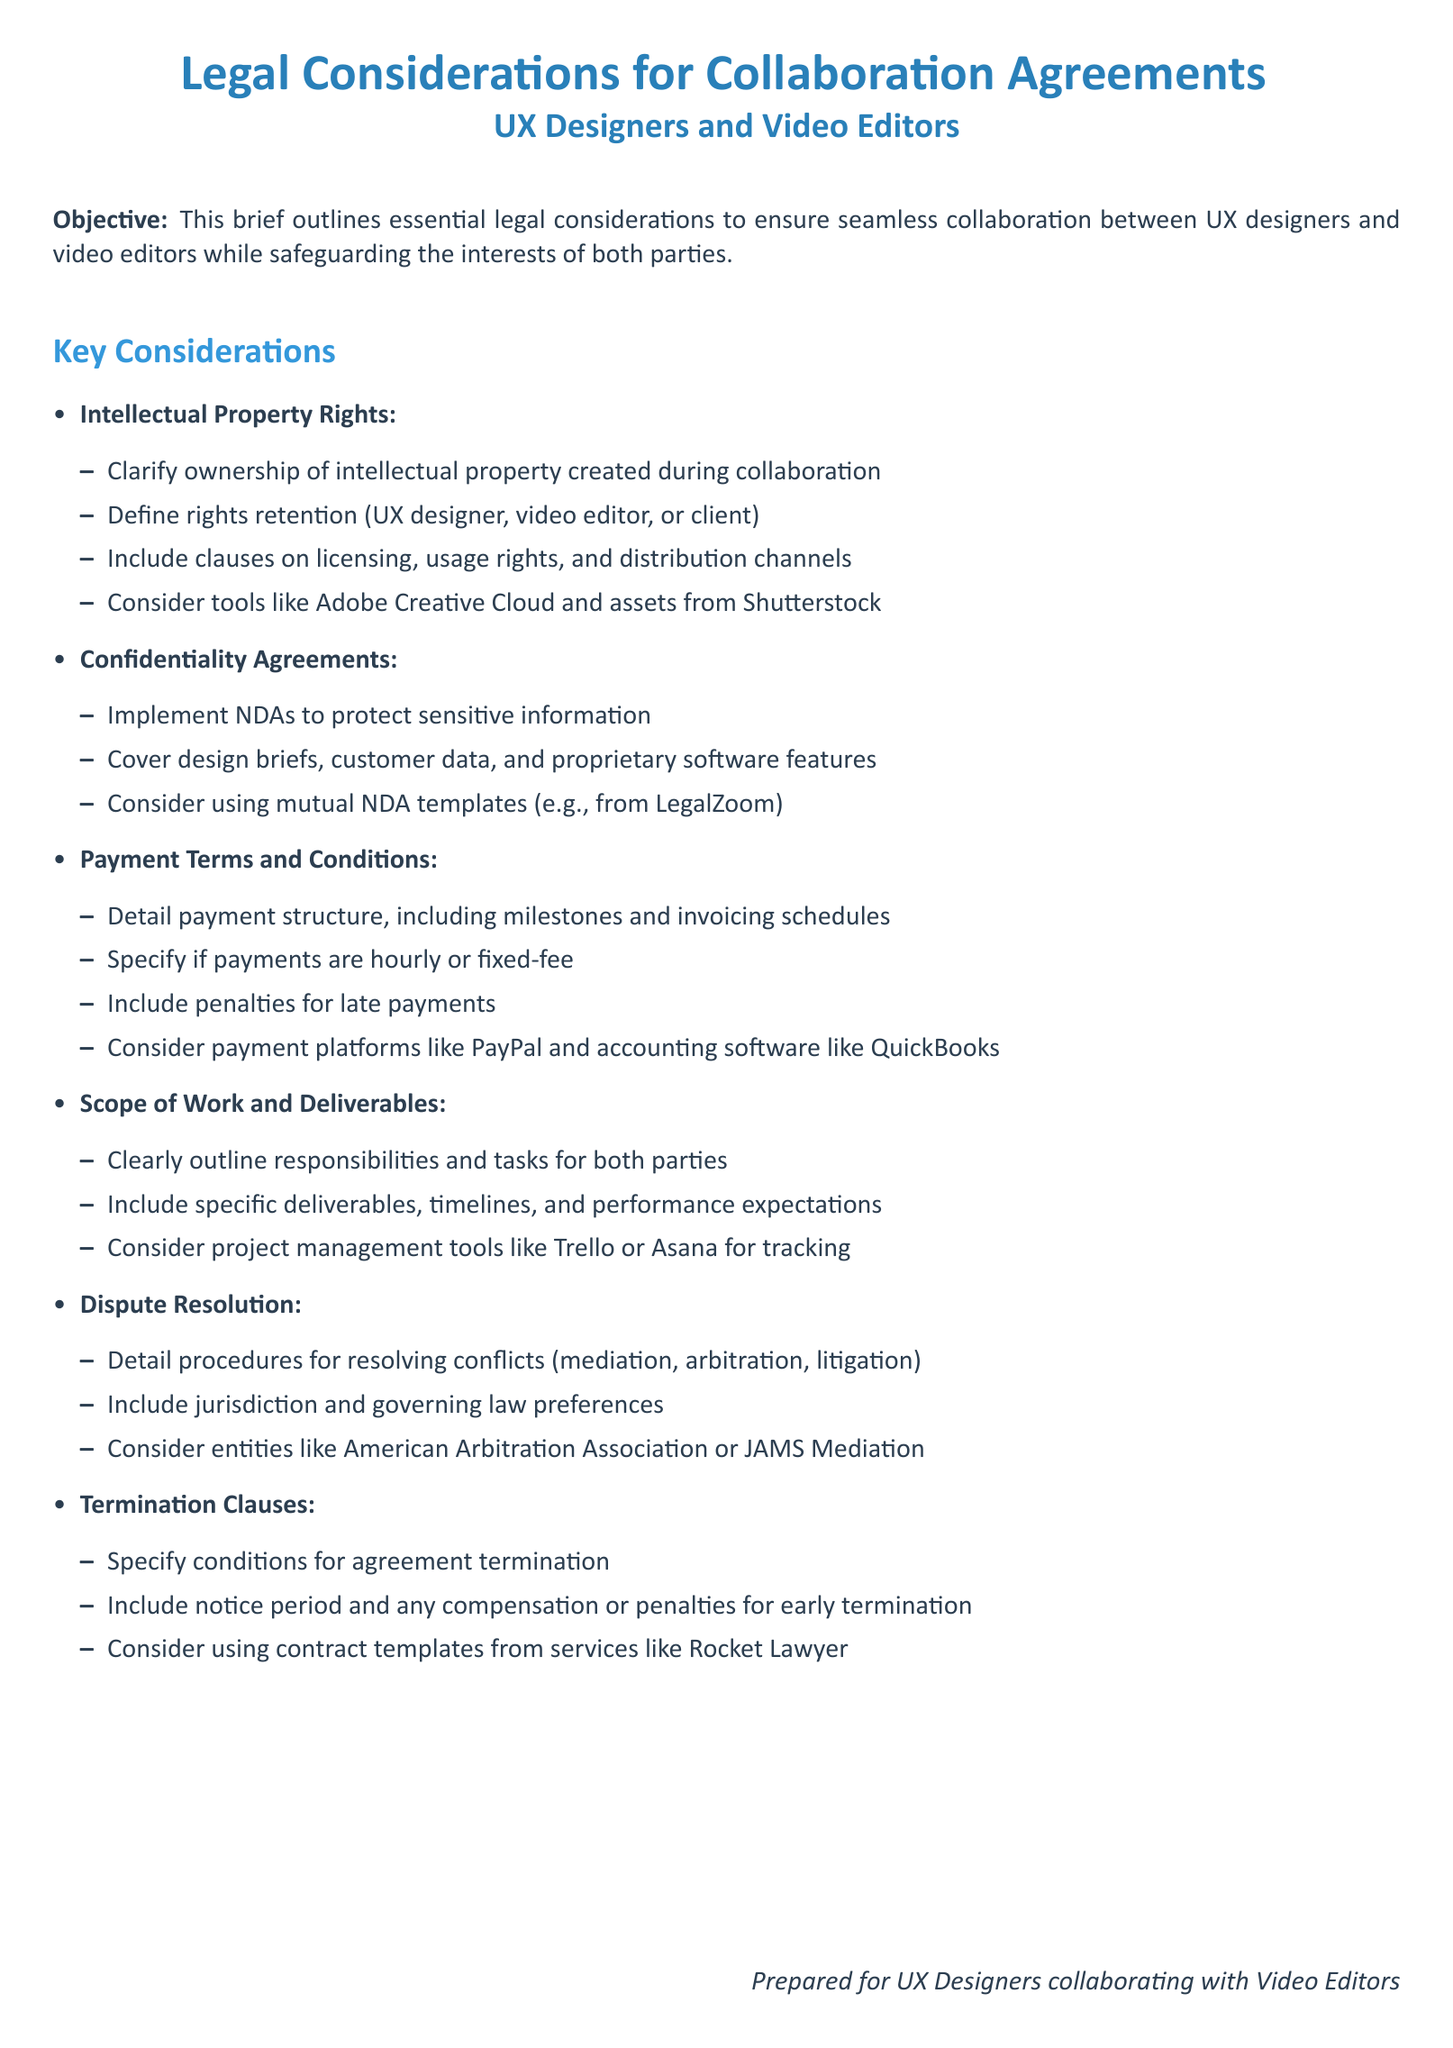What is the main objective of the brief? The objective outlines essential legal considerations for collaboration between UX designers and video editors.
Answer: Ensuring seamless collaboration What is the first key consideration mentioned in the document? The brief lists intellectual property rights as the first key consideration for collaborations.
Answer: Intellectual Property Rights Which type of agreement is suggested for protecting sensitive information? The document mentions implementing nondisclosure agreements (NDAs) for this purpose.
Answer: NDAs What should be detailed under payment terms? The payment structure, including milestones and invoicing schedules, must be specified for clarity.
Answer: Payment structure What does the brief recommend for resolving disputes? It details procedures such as mediation, arbitration, and litigation as ways to resolve conflicts.
Answer: Mediation, arbitration, litigation What type of clauses does the brief mention regarding agreement termination? The document specifies conditions for agreement termination as a necessary component of legal considerations.
Answer: Termination Clauses How does the brief suggest tracking responsibilities and tasks? It recommends using project management tools like Trello or Asana to track progress and responsibilities.
Answer: Trello, Asana What is the purpose of including a notice period in termination clauses? The notice period provides clarity on the timeline and expectations for ending the agreement.
Answer: Clarity on timeline Which entity is mentioned for dispute resolution? The brief mentions the American Arbitration Association as a possible entity for resolving disputes.
Answer: American Arbitration Association 